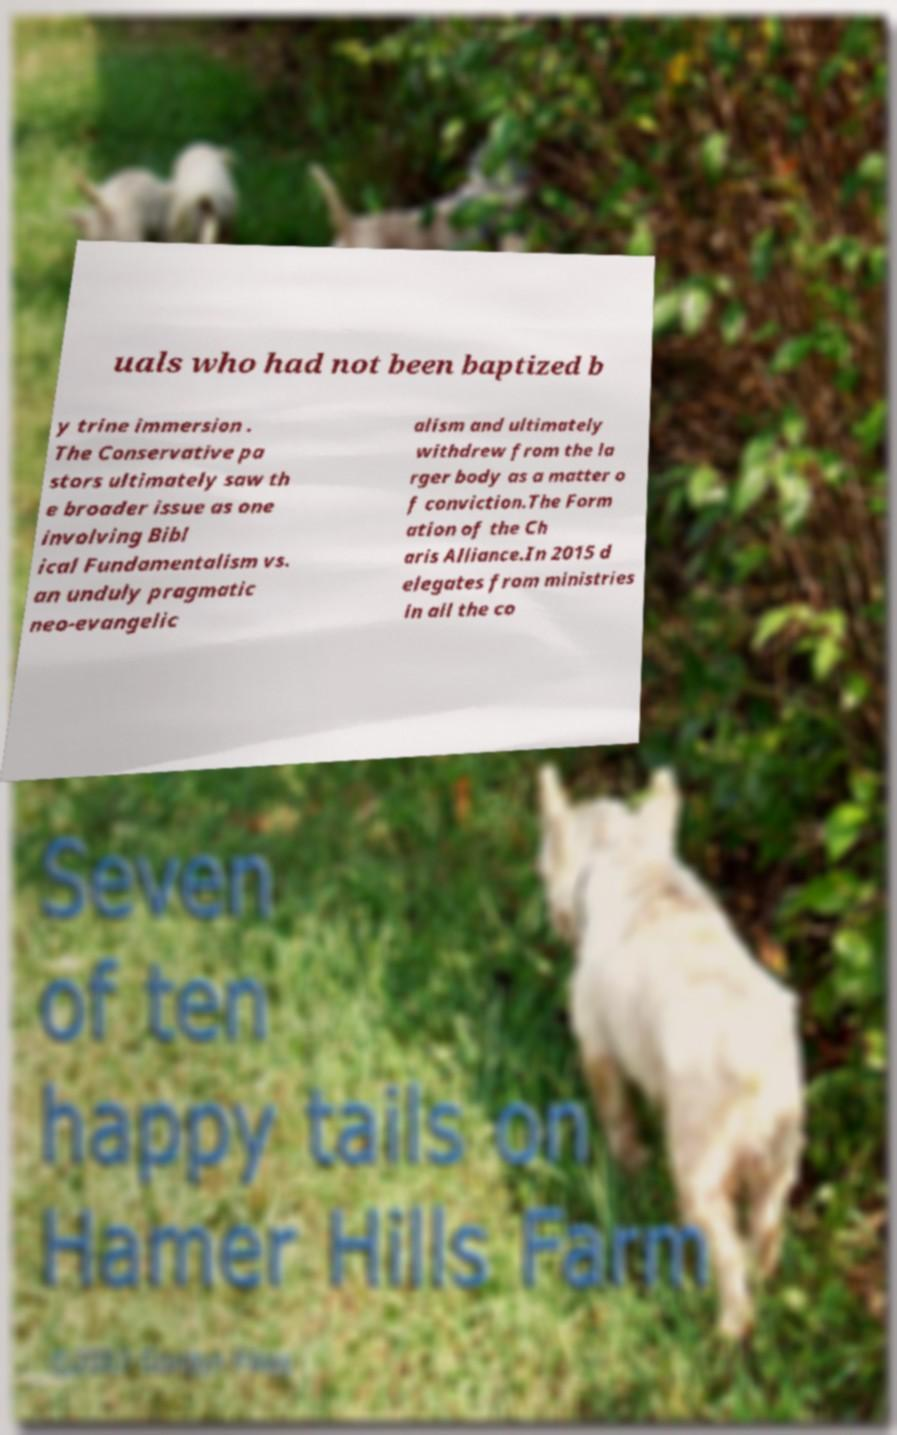Can you read and provide the text displayed in the image?This photo seems to have some interesting text. Can you extract and type it out for me? uals who had not been baptized b y trine immersion . The Conservative pa stors ultimately saw th e broader issue as one involving Bibl ical Fundamentalism vs. an unduly pragmatic neo-evangelic alism and ultimately withdrew from the la rger body as a matter o f conviction.The Form ation of the Ch aris Alliance.In 2015 d elegates from ministries in all the co 